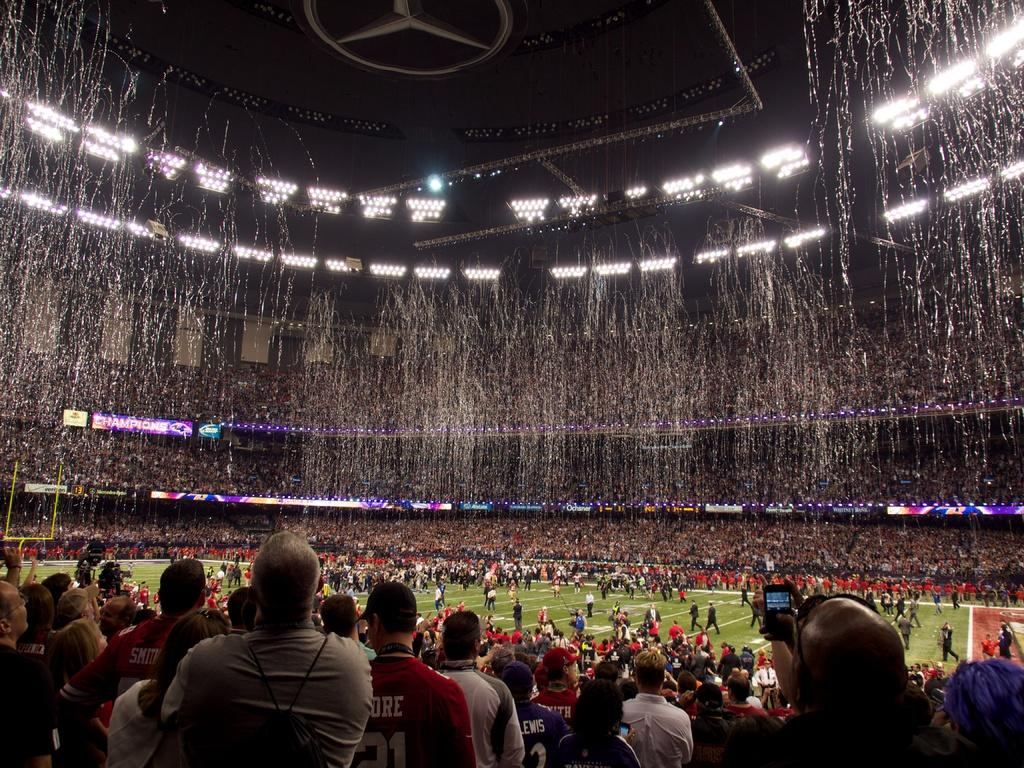What are the people in the image doing? There is a group of people sitting and a group of people standing in the image. Where are the people located? The people are on the ground in the image. What is happening in the background of the image? Water is falling in the image, and there are lights visible above. What type of cellar can be seen in the image? There is no cellar present in the image. What is being exchanged between the people in the image? The image does not show any exchange of items or actions between the people. 